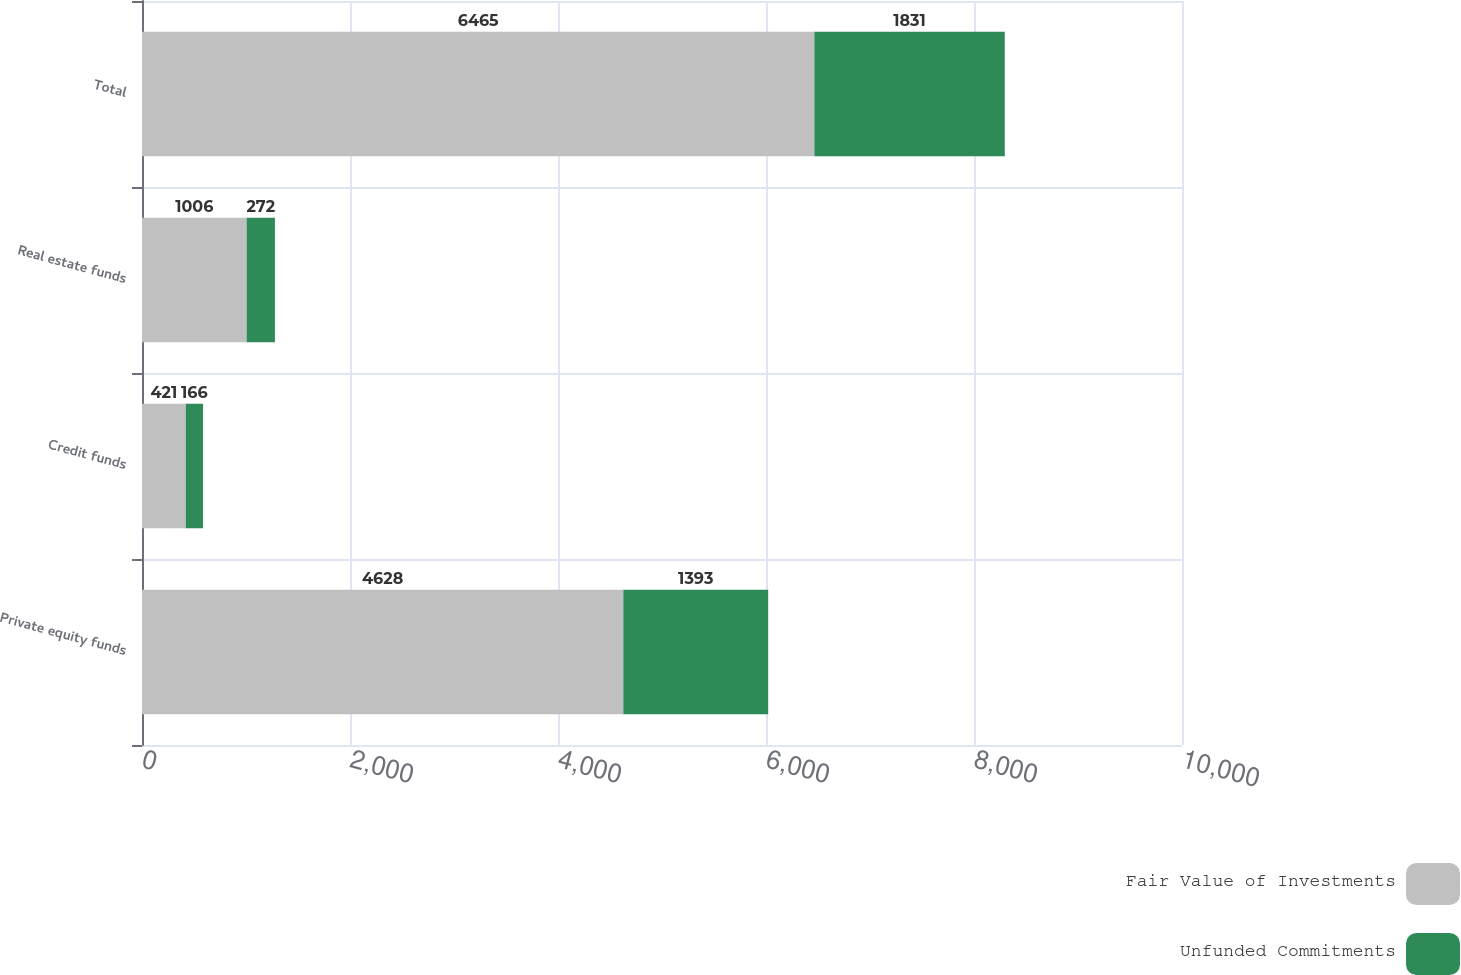Convert chart. <chart><loc_0><loc_0><loc_500><loc_500><stacked_bar_chart><ecel><fcel>Private equity funds<fcel>Credit funds<fcel>Real estate funds<fcel>Total<nl><fcel>Fair Value of Investments<fcel>4628<fcel>421<fcel>1006<fcel>6465<nl><fcel>Unfunded Commitments<fcel>1393<fcel>166<fcel>272<fcel>1831<nl></chart> 